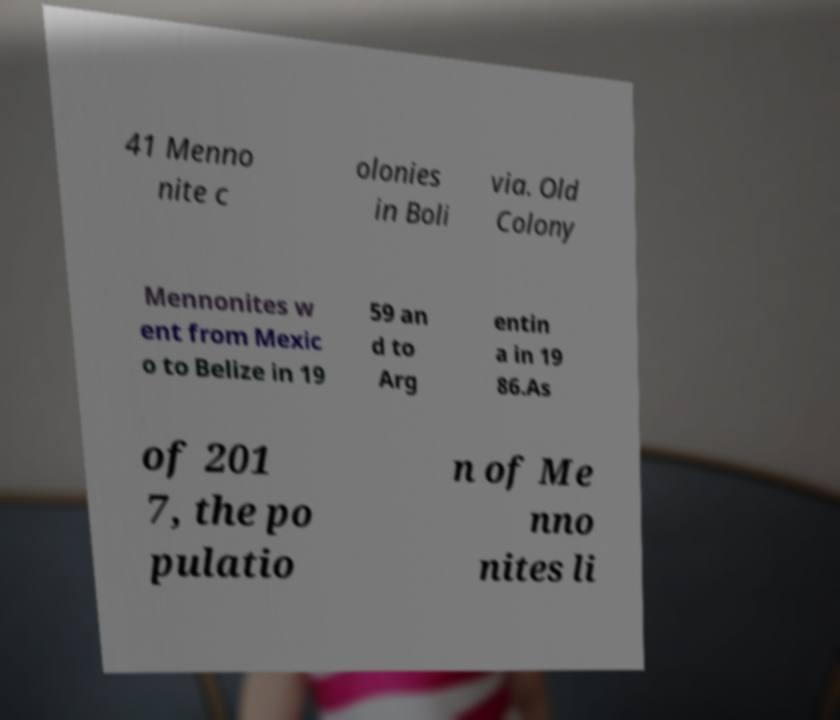Could you assist in decoding the text presented in this image and type it out clearly? 41 Menno nite c olonies in Boli via. Old Colony Mennonites w ent from Mexic o to Belize in 19 59 an d to Arg entin a in 19 86.As of 201 7, the po pulatio n of Me nno nites li 